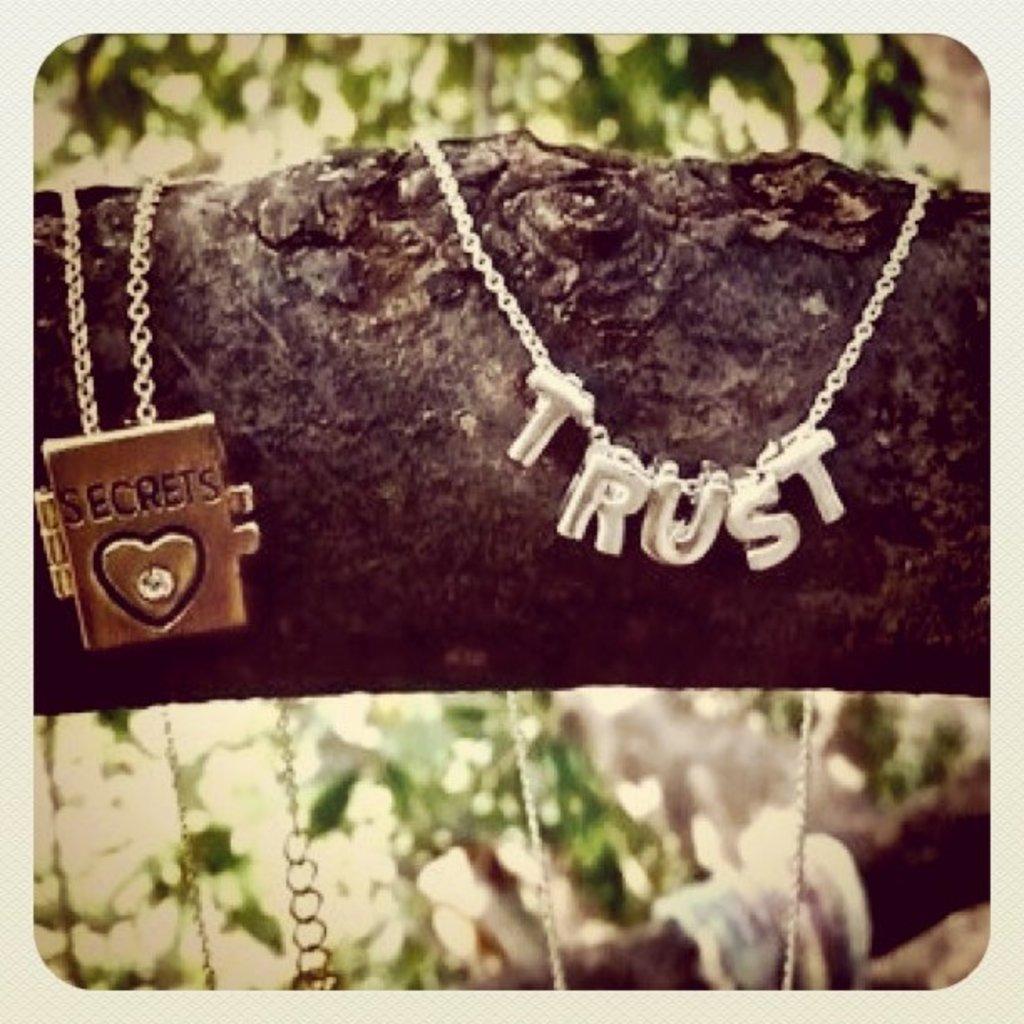Whats written on the cain?
Provide a short and direct response. Trust. 